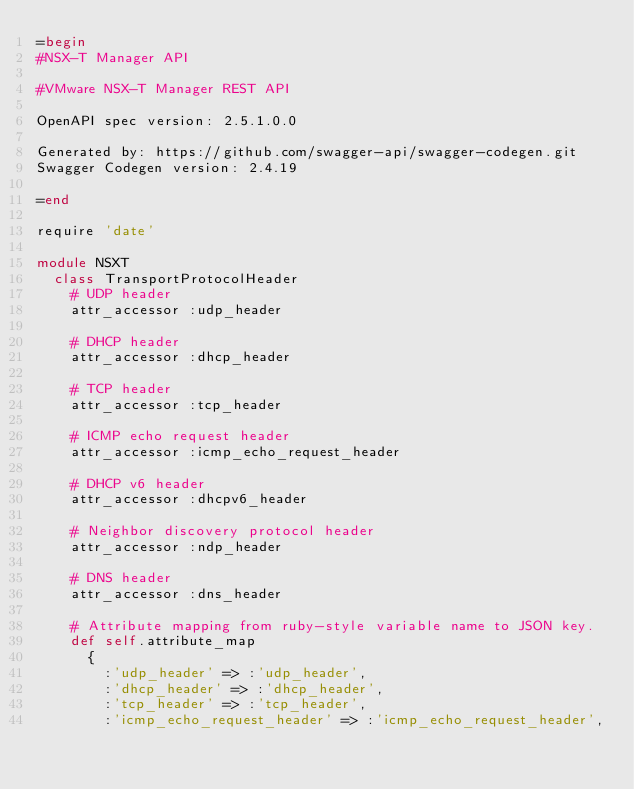<code> <loc_0><loc_0><loc_500><loc_500><_Ruby_>=begin
#NSX-T Manager API

#VMware NSX-T Manager REST API

OpenAPI spec version: 2.5.1.0.0

Generated by: https://github.com/swagger-api/swagger-codegen.git
Swagger Codegen version: 2.4.19

=end

require 'date'

module NSXT
  class TransportProtocolHeader
    # UDP header
    attr_accessor :udp_header

    # DHCP header
    attr_accessor :dhcp_header

    # TCP header
    attr_accessor :tcp_header

    # ICMP echo request header
    attr_accessor :icmp_echo_request_header

    # DHCP v6 header
    attr_accessor :dhcpv6_header

    # Neighbor discovery protocol header
    attr_accessor :ndp_header

    # DNS header
    attr_accessor :dns_header

    # Attribute mapping from ruby-style variable name to JSON key.
    def self.attribute_map
      {
        :'udp_header' => :'udp_header',
        :'dhcp_header' => :'dhcp_header',
        :'tcp_header' => :'tcp_header',
        :'icmp_echo_request_header' => :'icmp_echo_request_header',</code> 